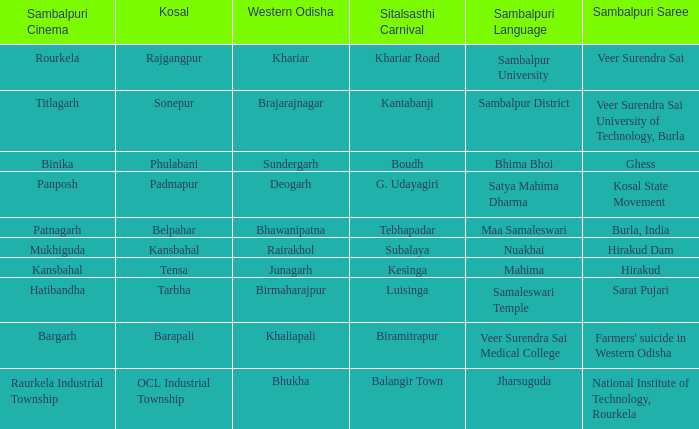What is the kosal featuring hatibandha in the sambalpuri film? Tarbha. 